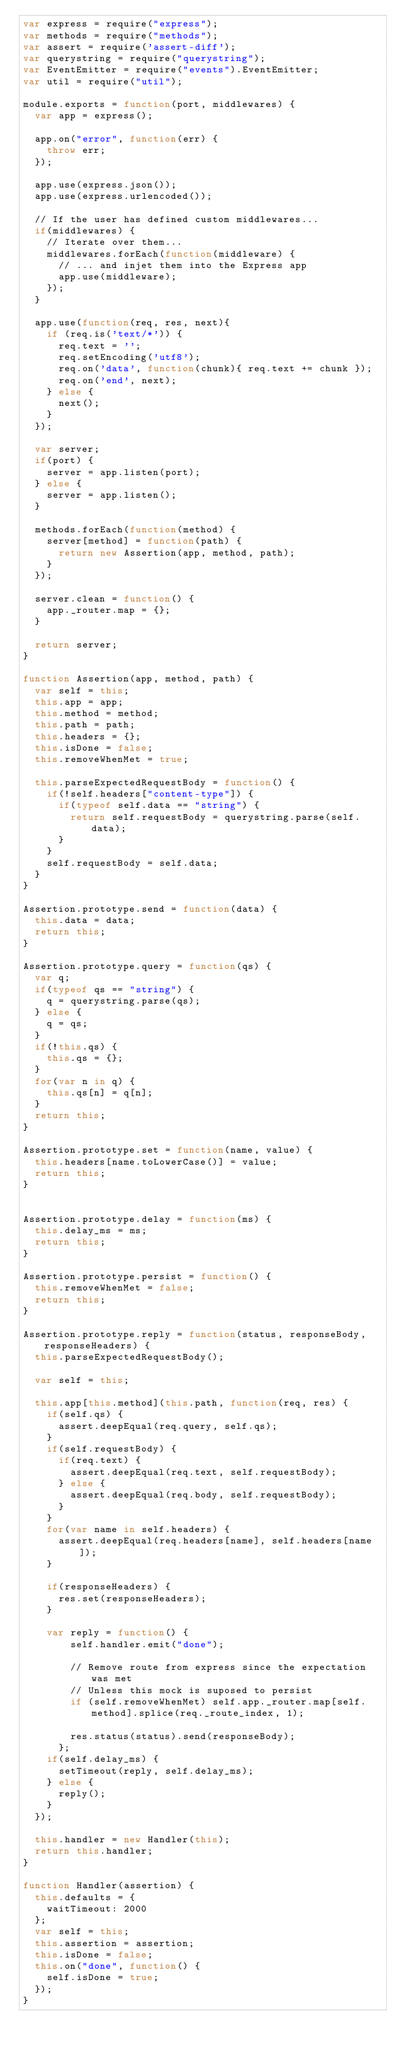Convert code to text. <code><loc_0><loc_0><loc_500><loc_500><_JavaScript_>var express = require("express");
var methods = require("methods");
var assert = require('assert-diff');
var querystring = require("querystring");
var EventEmitter = require("events").EventEmitter;
var util = require("util");

module.exports = function(port, middlewares) {
  var app = express();

  app.on("error", function(err) {
    throw err;
  });

  app.use(express.json());
  app.use(express.urlencoded());

  // If the user has defined custom middlewares...
  if(middlewares) {
    // Iterate over them...
    middlewares.forEach(function(middleware) {
      // ... and injet them into the Express app
      app.use(middleware);
    });
  }

  app.use(function(req, res, next){
    if (req.is('text/*')) {
      req.text = '';
      req.setEncoding('utf8');
      req.on('data', function(chunk){ req.text += chunk });
      req.on('end', next);
    } else {
      next();
    }
  });

  var server;
  if(port) {
    server = app.listen(port);
  } else {
    server = app.listen();
  }

  methods.forEach(function(method) {
    server[method] = function(path) {
      return new Assertion(app, method, path);
    }
  });

  server.clean = function() {
    app._router.map = {};
  }

  return server;
}

function Assertion(app, method, path) {
  var self = this;
  this.app = app;
  this.method = method;
  this.path = path;
  this.headers = {};
  this.isDone = false;
  this.removeWhenMet = true;

  this.parseExpectedRequestBody = function() {
    if(!self.headers["content-type"]) {
      if(typeof self.data == "string") {
        return self.requestBody = querystring.parse(self.data);
      }
    }
    self.requestBody = self.data;
  }
}

Assertion.prototype.send = function(data) {
  this.data = data;
  return this;
}

Assertion.prototype.query = function(qs) {
  var q;
  if(typeof qs == "string") {
    q = querystring.parse(qs);
  } else {
    q = qs;
  }
  if(!this.qs) {
    this.qs = {};
  }
  for(var n in q) {
    this.qs[n] = q[n];
  }
  return this;
}

Assertion.prototype.set = function(name, value) {
  this.headers[name.toLowerCase()] = value;
  return this;
}


Assertion.prototype.delay = function(ms) {
  this.delay_ms = ms;
  return this;
}

Assertion.prototype.persist = function() {
  this.removeWhenMet = false;
  return this;
}

Assertion.prototype.reply = function(status, responseBody, responseHeaders) {
  this.parseExpectedRequestBody();

  var self = this;

  this.app[this.method](this.path, function(req, res) {
    if(self.qs) {
      assert.deepEqual(req.query, self.qs);
    }
    if(self.requestBody) {
      if(req.text) {
        assert.deepEqual(req.text, self.requestBody);
      } else {
        assert.deepEqual(req.body, self.requestBody);
      }
    }
    for(var name in self.headers) {
      assert.deepEqual(req.headers[name], self.headers[name]);
    }

    if(responseHeaders) {
      res.set(responseHeaders);
    }

    var reply = function() {
        self.handler.emit("done");

        // Remove route from express since the expectation was met
        // Unless this mock is suposed to persist
        if (self.removeWhenMet) self.app._router.map[self.method].splice(req._route_index, 1);

        res.status(status).send(responseBody);
      };
    if(self.delay_ms) {
      setTimeout(reply, self.delay_ms);
    } else {
      reply();
    }
  });

  this.handler = new Handler(this);
  return this.handler;
}

function Handler(assertion) {
  this.defaults = {
    waitTimeout: 2000
  };
  var self = this;
  this.assertion = assertion;
  this.isDone = false;
  this.on("done", function() {
    self.isDone = true;
  });
}
</code> 